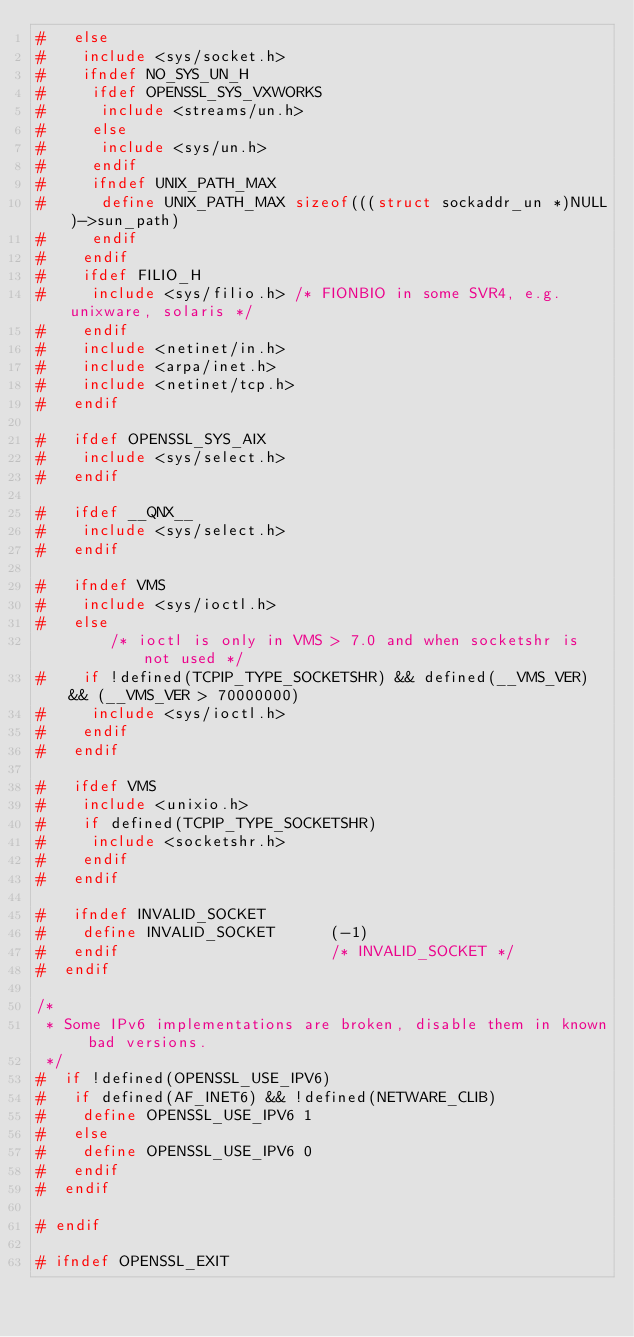Convert code to text. <code><loc_0><loc_0><loc_500><loc_500><_C_>#   else
#    include <sys/socket.h>
#    ifndef NO_SYS_UN_H
#     ifdef OPENSSL_SYS_VXWORKS
#      include <streams/un.h>
#     else
#      include <sys/un.h>
#     endif
#     ifndef UNIX_PATH_MAX
#      define UNIX_PATH_MAX sizeof(((struct sockaddr_un *)NULL)->sun_path)
#     endif
#    endif
#    ifdef FILIO_H
#     include <sys/filio.h> /* FIONBIO in some SVR4, e.g. unixware, solaris */
#    endif
#    include <netinet/in.h>
#    include <arpa/inet.h>
#    include <netinet/tcp.h>
#   endif

#   ifdef OPENSSL_SYS_AIX
#    include <sys/select.h>
#   endif

#   ifdef __QNX__
#    include <sys/select.h>
#   endif

#   ifndef VMS
#    include <sys/ioctl.h>
#   else
        /* ioctl is only in VMS > 7.0 and when socketshr is not used */
#    if !defined(TCPIP_TYPE_SOCKETSHR) && defined(__VMS_VER) && (__VMS_VER > 70000000)
#     include <sys/ioctl.h>
#    endif
#   endif

#   ifdef VMS
#    include <unixio.h>
#    if defined(TCPIP_TYPE_SOCKETSHR)
#     include <socketshr.h>
#    endif
#   endif

#   ifndef INVALID_SOCKET
#    define INVALID_SOCKET      (-1)
#   endif                       /* INVALID_SOCKET */
#  endif

/*
 * Some IPv6 implementations are broken, disable them in known bad versions.
 */
#  if !defined(OPENSSL_USE_IPV6)
#   if defined(AF_INET6) && !defined(NETWARE_CLIB)
#    define OPENSSL_USE_IPV6 1
#   else
#    define OPENSSL_USE_IPV6 0
#   endif
#  endif

# endif

# ifndef OPENSSL_EXIT</code> 